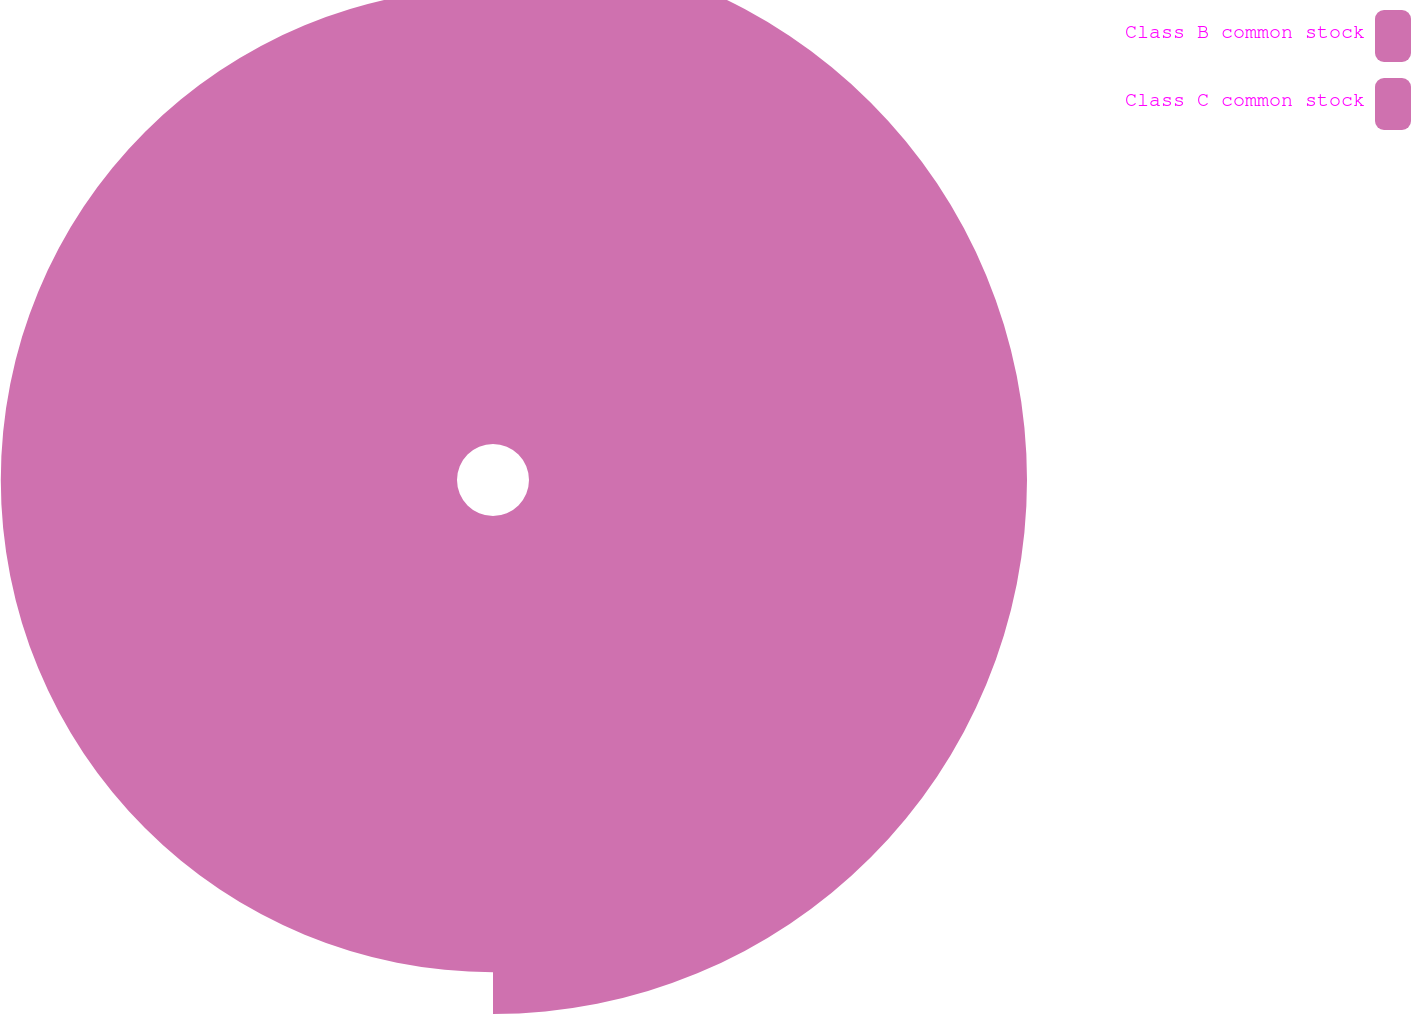Convert chart. <chart><loc_0><loc_0><loc_500><loc_500><pie_chart><fcel>Class B common stock<fcel>Class C common stock<nl><fcel>52.19%<fcel>47.81%<nl></chart> 